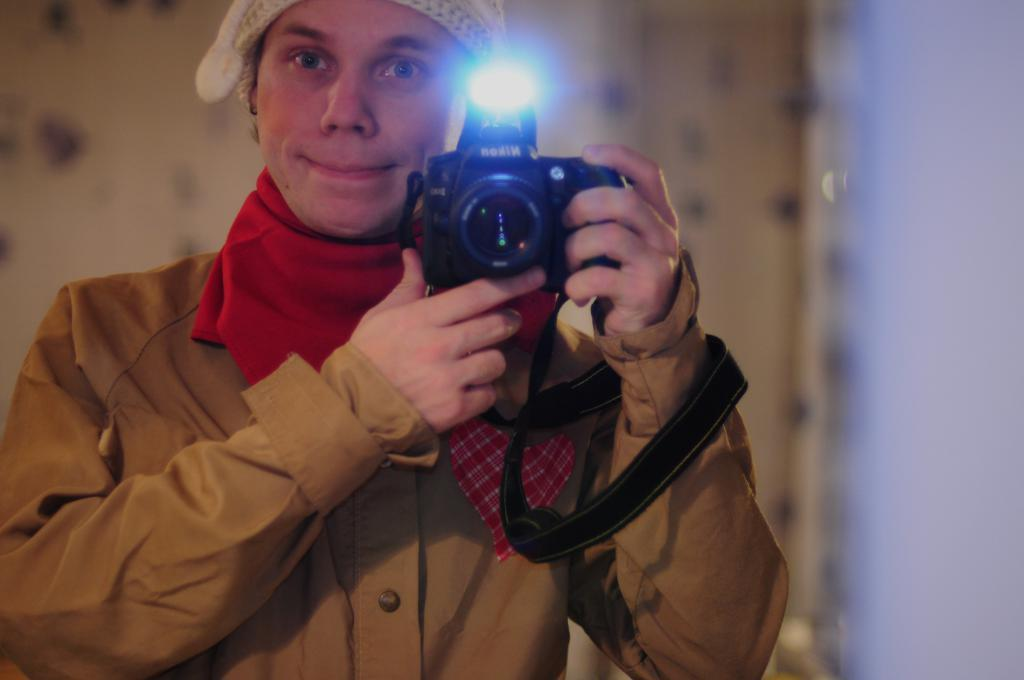Who is the main subject in the image? There is a woman in the image. Where is the woman located in the image? The woman is on the right side of the image. What is the woman holding in her hand? The woman is holding a camera in her hand. What type of animal is the woman trying to copy in the image? There is no animal present in the image, and the woman is not trying to copy any animal. 